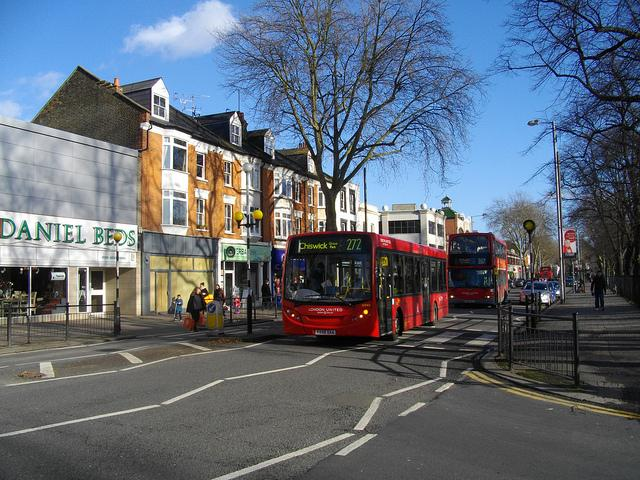What season is it in the image?

Choices:
A) spring
B) summer
C) spring-summer
D) fall-winter fall-winter 